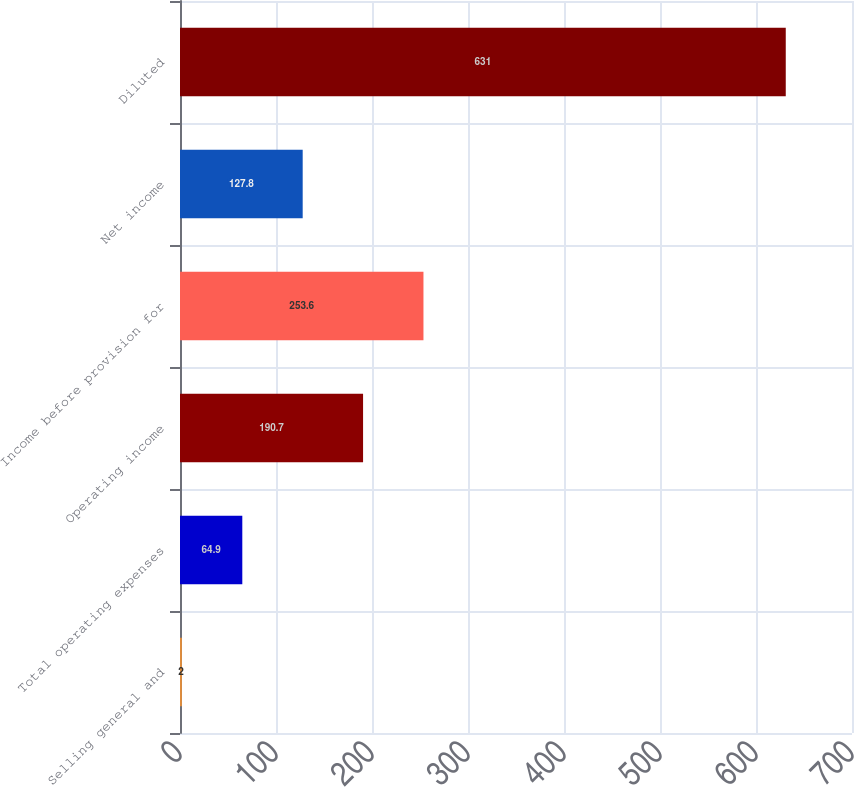Convert chart to OTSL. <chart><loc_0><loc_0><loc_500><loc_500><bar_chart><fcel>Selling general and<fcel>Total operating expenses<fcel>Operating income<fcel>Income before provision for<fcel>Net income<fcel>Diluted<nl><fcel>2<fcel>64.9<fcel>190.7<fcel>253.6<fcel>127.8<fcel>631<nl></chart> 